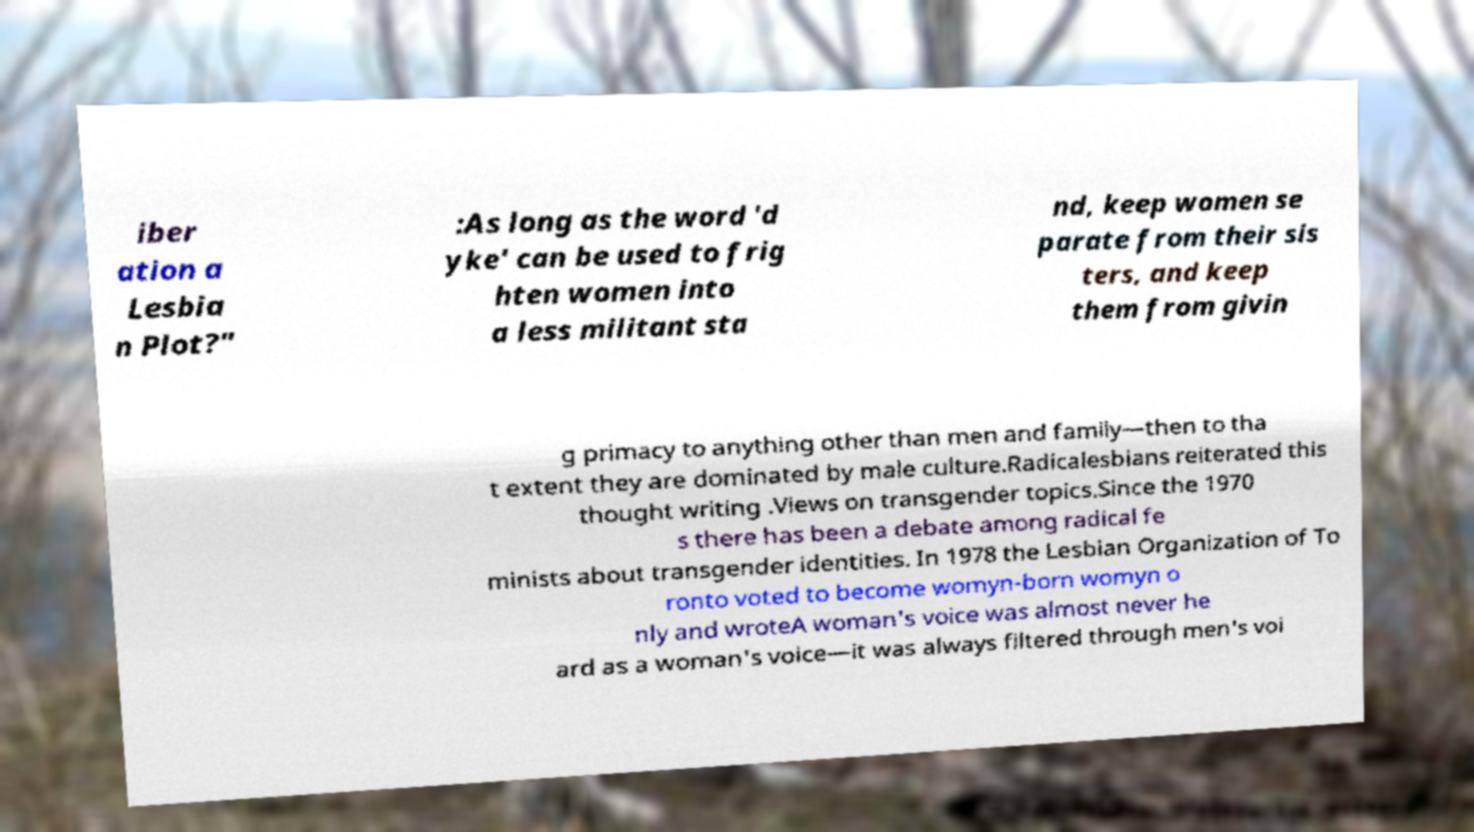For documentation purposes, I need the text within this image transcribed. Could you provide that? iber ation a Lesbia n Plot?" :As long as the word 'd yke' can be used to frig hten women into a less militant sta nd, keep women se parate from their sis ters, and keep them from givin g primacy to anything other than men and family—then to tha t extent they are dominated by male culture.Radicalesbians reiterated this thought writing .Views on transgender topics.Since the 1970 s there has been a debate among radical fe minists about transgender identities. In 1978 the Lesbian Organization of To ronto voted to become womyn-born womyn o nly and wroteA woman's voice was almost never he ard as a woman's voice—it was always filtered through men's voi 